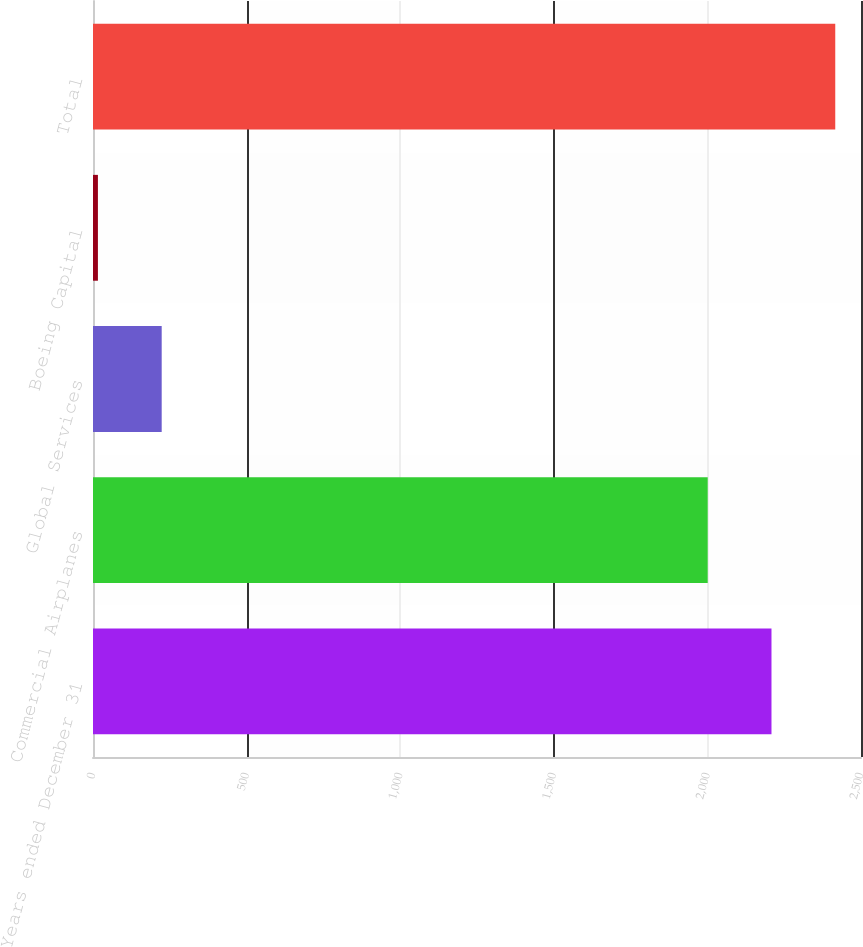Convert chart. <chart><loc_0><loc_0><loc_500><loc_500><bar_chart><fcel>Years ended December 31<fcel>Commercial Airplanes<fcel>Global Services<fcel>Boeing Capital<fcel>Total<nl><fcel>2208.6<fcel>2001<fcel>223.6<fcel>16<fcel>2416.2<nl></chart> 